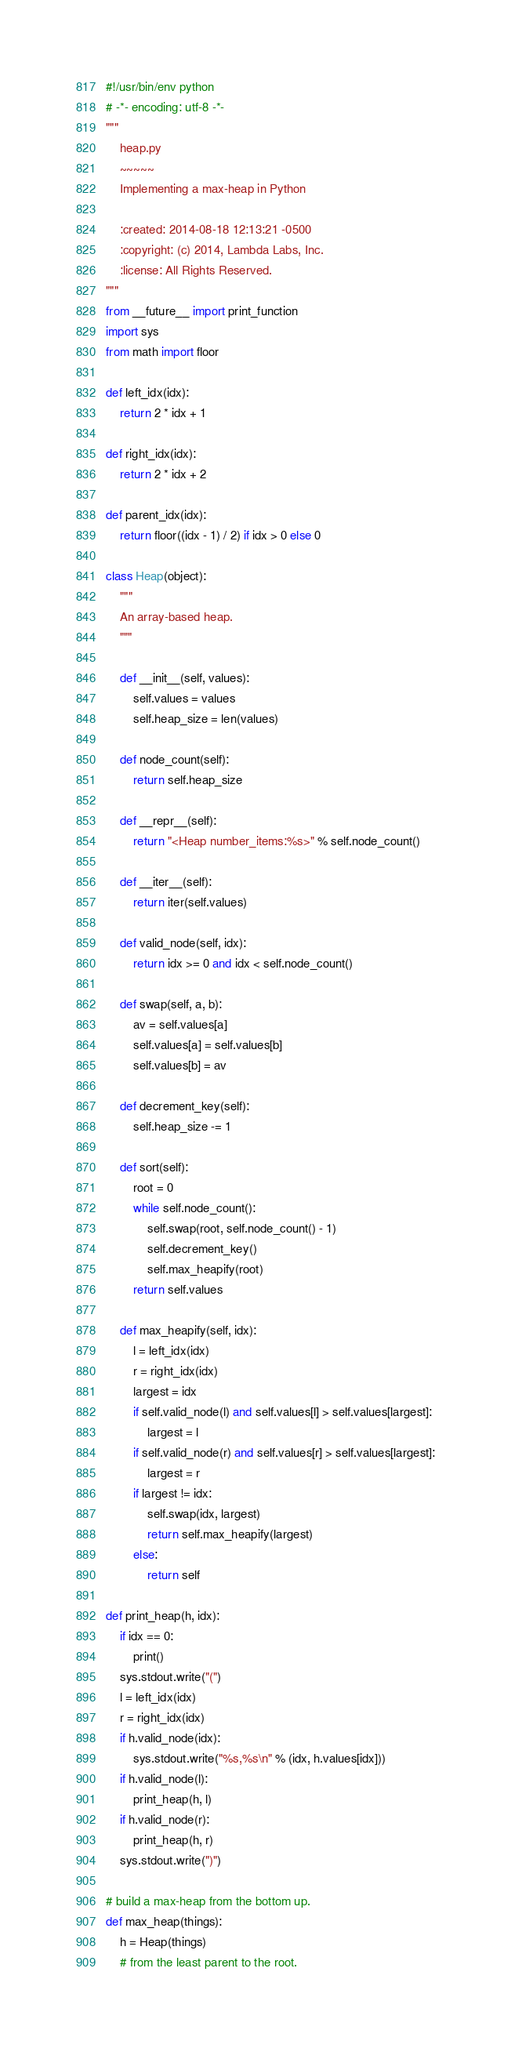Convert code to text. <code><loc_0><loc_0><loc_500><loc_500><_Python_>#!/usr/bin/env python
# -*- encoding: utf-8 -*-
"""
    heap.py
    ~~~~~
    Implementing a max-heap in Python

    :created: 2014-08-18 12:13:21 -0500
    :copyright: (c) 2014, Lambda Labs, Inc.
    :license: All Rights Reserved.
"""
from __future__ import print_function
import sys
from math import floor

def left_idx(idx):
    return 2 * idx + 1

def right_idx(idx):
    return 2 * idx + 2

def parent_idx(idx):
    return floor((idx - 1) / 2) if idx > 0 else 0

class Heap(object):
    """
    An array-based heap.
    """

    def __init__(self, values):
        self.values = values
        self.heap_size = len(values)

    def node_count(self):
        return self.heap_size

    def __repr__(self):
        return "<Heap number_items:%s>" % self.node_count()

    def __iter__(self):
        return iter(self.values)

    def valid_node(self, idx):
        return idx >= 0 and idx < self.node_count()

    def swap(self, a, b):
        av = self.values[a]
        self.values[a] = self.values[b]
        self.values[b] = av

    def decrement_key(self):
        self.heap_size -= 1

    def sort(self):
        root = 0
        while self.node_count():
            self.swap(root, self.node_count() - 1)
            self.decrement_key()
            self.max_heapify(root)
        return self.values

    def max_heapify(self, idx):
        l = left_idx(idx)
        r = right_idx(idx)
        largest = idx
        if self.valid_node(l) and self.values[l] > self.values[largest]:
            largest = l
        if self.valid_node(r) and self.values[r] > self.values[largest]:
            largest = r
        if largest != idx:
            self.swap(idx, largest)
            return self.max_heapify(largest)
        else:
            return self

def print_heap(h, idx):
    if idx == 0:
        print()
    sys.stdout.write("(")
    l = left_idx(idx)
    r = right_idx(idx)
    if h.valid_node(idx):
        sys.stdout.write("%s,%s\n" % (idx, h.values[idx]))
    if h.valid_node(l):
        print_heap(h, l)
    if h.valid_node(r):
        print_heap(h, r)
    sys.stdout.write(")")

# build a max-heap from the bottom up.
def max_heap(things):
    h = Heap(things)
    # from the least parent to the root.</code> 